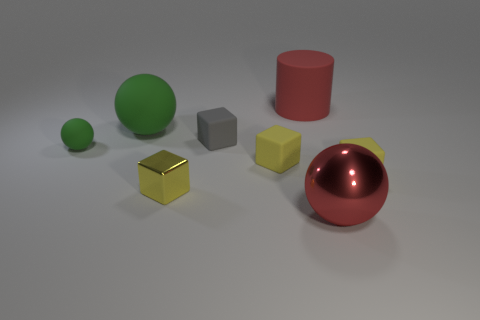How many yellow cubes must be subtracted to get 1 yellow cubes? 2 Subtract all yellow balls. How many yellow blocks are left? 3 Subtract 1 cubes. How many cubes are left? 3 Subtract all cyan balls. Subtract all gray blocks. How many balls are left? 3 Add 1 large cyan metal blocks. How many objects exist? 9 Subtract all balls. How many objects are left? 5 Subtract all tiny rubber objects. Subtract all large rubber cylinders. How many objects are left? 3 Add 6 tiny green rubber balls. How many tiny green rubber balls are left? 7 Add 5 tiny cyan metallic objects. How many tiny cyan metallic objects exist? 5 Subtract 0 purple balls. How many objects are left? 8 